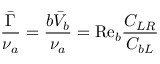Convert formula to latex. <formula><loc_0><loc_0><loc_500><loc_500>\frac { \bar { \Gamma } } { \nu _ { a } } = \frac { b \bar { V } _ { b } } { \nu _ { a } } = R e _ { b } \frac { C _ { L R } } { C _ { b L } }</formula> 